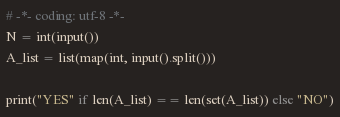<code> <loc_0><loc_0><loc_500><loc_500><_Python_># -*- coding: utf-8 -*-
N = int(input())
A_list = list(map(int, input().split()))

print("YES" if len(A_list) == len(set(A_list)) else "NO")</code> 